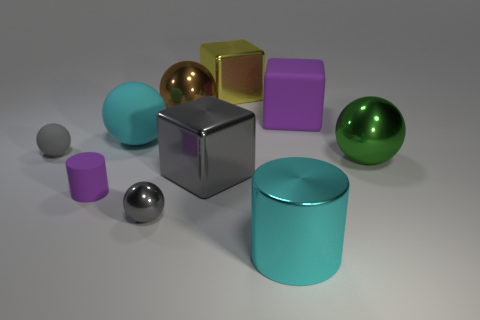How many gray spheres must be subtracted to get 1 gray spheres? 1 Subtract all brown metallic spheres. How many spheres are left? 4 Subtract all gray balls. How many balls are left? 3 Subtract all blocks. How many objects are left? 7 Subtract 2 spheres. How many spheres are left? 3 Subtract all brown cubes. How many cyan cylinders are left? 1 Add 2 brown metallic spheres. How many brown metallic spheres exist? 3 Subtract 0 yellow balls. How many objects are left? 10 Subtract all cyan spheres. Subtract all purple cubes. How many spheres are left? 4 Subtract all red matte balls. Subtract all big green metallic objects. How many objects are left? 9 